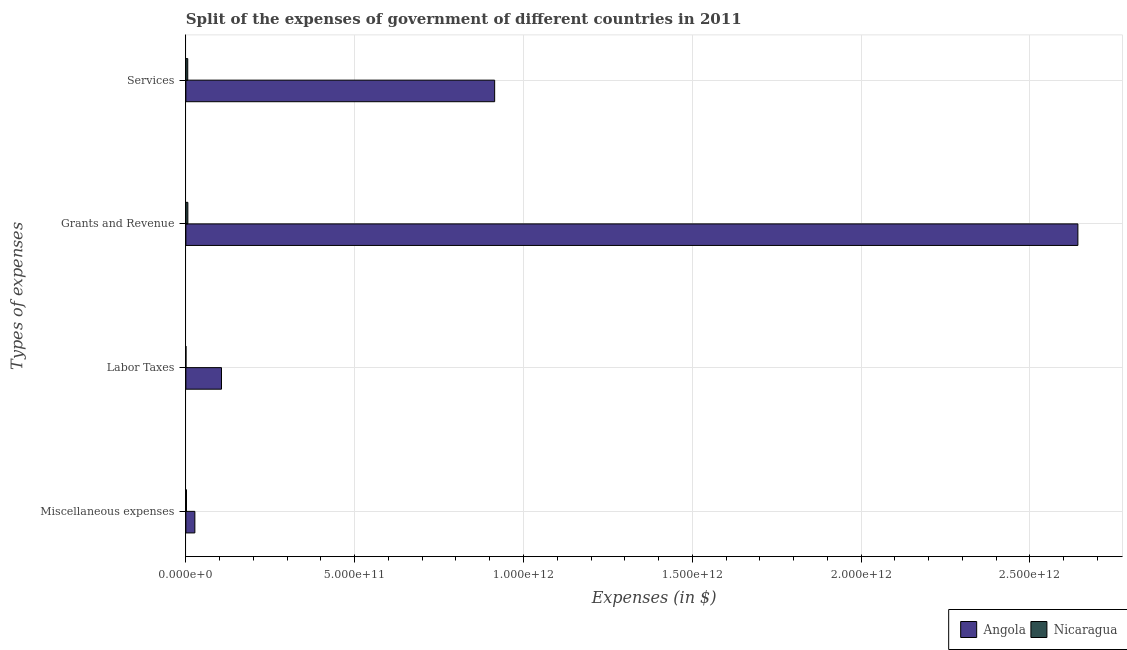Are the number of bars per tick equal to the number of legend labels?
Your answer should be very brief. Yes. How many bars are there on the 1st tick from the top?
Your response must be concise. 2. How many bars are there on the 3rd tick from the bottom?
Keep it short and to the point. 2. What is the label of the 4th group of bars from the top?
Ensure brevity in your answer.  Miscellaneous expenses. What is the amount spent on services in Angola?
Give a very brief answer. 9.15e+11. Across all countries, what is the maximum amount spent on grants and revenue?
Provide a succinct answer. 2.64e+12. Across all countries, what is the minimum amount spent on services?
Offer a terse response. 5.54e+09. In which country was the amount spent on services maximum?
Give a very brief answer. Angola. In which country was the amount spent on services minimum?
Make the answer very short. Nicaragua. What is the total amount spent on miscellaneous expenses in the graph?
Your answer should be very brief. 2.84e+1. What is the difference between the amount spent on miscellaneous expenses in Nicaragua and that in Angola?
Provide a short and direct response. -2.48e+1. What is the difference between the amount spent on miscellaneous expenses in Nicaragua and the amount spent on grants and revenue in Angola?
Your response must be concise. -2.64e+12. What is the average amount spent on grants and revenue per country?
Ensure brevity in your answer.  1.32e+12. What is the difference between the amount spent on miscellaneous expenses and amount spent on labor taxes in Nicaragua?
Keep it short and to the point. 1.59e+09. In how many countries, is the amount spent on miscellaneous expenses greater than 500000000000 $?
Your answer should be very brief. 0. What is the ratio of the amount spent on grants and revenue in Angola to that in Nicaragua?
Provide a succinct answer. 450.04. What is the difference between the highest and the second highest amount spent on services?
Your response must be concise. 9.09e+11. What is the difference between the highest and the lowest amount spent on miscellaneous expenses?
Offer a terse response. 2.48e+1. In how many countries, is the amount spent on labor taxes greater than the average amount spent on labor taxes taken over all countries?
Your answer should be compact. 1. What does the 2nd bar from the top in Services represents?
Keep it short and to the point. Angola. What does the 1st bar from the bottom in Miscellaneous expenses represents?
Ensure brevity in your answer.  Angola. Is it the case that in every country, the sum of the amount spent on miscellaneous expenses and amount spent on labor taxes is greater than the amount spent on grants and revenue?
Offer a very short reply. No. Are all the bars in the graph horizontal?
Ensure brevity in your answer.  Yes. How many countries are there in the graph?
Ensure brevity in your answer.  2. What is the difference between two consecutive major ticks on the X-axis?
Make the answer very short. 5.00e+11. Does the graph contain any zero values?
Provide a succinct answer. No. Does the graph contain grids?
Your answer should be compact. Yes. Where does the legend appear in the graph?
Provide a short and direct response. Bottom right. How many legend labels are there?
Keep it short and to the point. 2. How are the legend labels stacked?
Your answer should be compact. Horizontal. What is the title of the graph?
Offer a very short reply. Split of the expenses of government of different countries in 2011. Does "Burkina Faso" appear as one of the legend labels in the graph?
Keep it short and to the point. No. What is the label or title of the X-axis?
Keep it short and to the point. Expenses (in $). What is the label or title of the Y-axis?
Ensure brevity in your answer.  Types of expenses. What is the Expenses (in $) in Angola in Miscellaneous expenses?
Give a very brief answer. 2.66e+1. What is the Expenses (in $) of Nicaragua in Miscellaneous expenses?
Ensure brevity in your answer.  1.80e+09. What is the Expenses (in $) in Angola in Labor Taxes?
Make the answer very short. 1.06e+11. What is the Expenses (in $) of Nicaragua in Labor Taxes?
Give a very brief answer. 2.13e+08. What is the Expenses (in $) in Angola in Grants and Revenue?
Provide a succinct answer. 2.64e+12. What is the Expenses (in $) in Nicaragua in Grants and Revenue?
Make the answer very short. 5.87e+09. What is the Expenses (in $) in Angola in Services?
Provide a short and direct response. 9.15e+11. What is the Expenses (in $) of Nicaragua in Services?
Your answer should be very brief. 5.54e+09. Across all Types of expenses, what is the maximum Expenses (in $) in Angola?
Your answer should be compact. 2.64e+12. Across all Types of expenses, what is the maximum Expenses (in $) of Nicaragua?
Your answer should be very brief. 5.87e+09. Across all Types of expenses, what is the minimum Expenses (in $) of Angola?
Provide a short and direct response. 2.66e+1. Across all Types of expenses, what is the minimum Expenses (in $) of Nicaragua?
Keep it short and to the point. 2.13e+08. What is the total Expenses (in $) of Angola in the graph?
Your answer should be very brief. 3.69e+12. What is the total Expenses (in $) of Nicaragua in the graph?
Your response must be concise. 1.34e+1. What is the difference between the Expenses (in $) of Angola in Miscellaneous expenses and that in Labor Taxes?
Give a very brief answer. -7.89e+1. What is the difference between the Expenses (in $) of Nicaragua in Miscellaneous expenses and that in Labor Taxes?
Give a very brief answer. 1.59e+09. What is the difference between the Expenses (in $) in Angola in Miscellaneous expenses and that in Grants and Revenue?
Offer a very short reply. -2.62e+12. What is the difference between the Expenses (in $) in Nicaragua in Miscellaneous expenses and that in Grants and Revenue?
Make the answer very short. -4.07e+09. What is the difference between the Expenses (in $) in Angola in Miscellaneous expenses and that in Services?
Your answer should be very brief. -8.88e+11. What is the difference between the Expenses (in $) in Nicaragua in Miscellaneous expenses and that in Services?
Your answer should be very brief. -3.74e+09. What is the difference between the Expenses (in $) of Angola in Labor Taxes and that in Grants and Revenue?
Provide a succinct answer. -2.54e+12. What is the difference between the Expenses (in $) of Nicaragua in Labor Taxes and that in Grants and Revenue?
Give a very brief answer. -5.66e+09. What is the difference between the Expenses (in $) in Angola in Labor Taxes and that in Services?
Provide a succinct answer. -8.09e+11. What is the difference between the Expenses (in $) in Nicaragua in Labor Taxes and that in Services?
Offer a very short reply. -5.32e+09. What is the difference between the Expenses (in $) in Angola in Grants and Revenue and that in Services?
Your response must be concise. 1.73e+12. What is the difference between the Expenses (in $) in Nicaragua in Grants and Revenue and that in Services?
Provide a succinct answer. 3.34e+08. What is the difference between the Expenses (in $) of Angola in Miscellaneous expenses and the Expenses (in $) of Nicaragua in Labor Taxes?
Your response must be concise. 2.64e+1. What is the difference between the Expenses (in $) of Angola in Miscellaneous expenses and the Expenses (in $) of Nicaragua in Grants and Revenue?
Your answer should be compact. 2.07e+1. What is the difference between the Expenses (in $) of Angola in Miscellaneous expenses and the Expenses (in $) of Nicaragua in Services?
Keep it short and to the point. 2.11e+1. What is the difference between the Expenses (in $) of Angola in Labor Taxes and the Expenses (in $) of Nicaragua in Grants and Revenue?
Give a very brief answer. 9.96e+1. What is the difference between the Expenses (in $) in Angola in Labor Taxes and the Expenses (in $) in Nicaragua in Services?
Keep it short and to the point. 1.00e+11. What is the difference between the Expenses (in $) in Angola in Grants and Revenue and the Expenses (in $) in Nicaragua in Services?
Provide a succinct answer. 2.64e+12. What is the average Expenses (in $) of Angola per Types of expenses?
Your answer should be compact. 9.22e+11. What is the average Expenses (in $) of Nicaragua per Types of expenses?
Provide a short and direct response. 3.36e+09. What is the difference between the Expenses (in $) in Angola and Expenses (in $) in Nicaragua in Miscellaneous expenses?
Provide a succinct answer. 2.48e+1. What is the difference between the Expenses (in $) in Angola and Expenses (in $) in Nicaragua in Labor Taxes?
Provide a short and direct response. 1.05e+11. What is the difference between the Expenses (in $) in Angola and Expenses (in $) in Nicaragua in Grants and Revenue?
Keep it short and to the point. 2.64e+12. What is the difference between the Expenses (in $) in Angola and Expenses (in $) in Nicaragua in Services?
Your response must be concise. 9.09e+11. What is the ratio of the Expenses (in $) in Angola in Miscellaneous expenses to that in Labor Taxes?
Make the answer very short. 0.25. What is the ratio of the Expenses (in $) in Nicaragua in Miscellaneous expenses to that in Labor Taxes?
Your answer should be very brief. 8.44. What is the ratio of the Expenses (in $) of Angola in Miscellaneous expenses to that in Grants and Revenue?
Offer a terse response. 0.01. What is the ratio of the Expenses (in $) of Nicaragua in Miscellaneous expenses to that in Grants and Revenue?
Ensure brevity in your answer.  0.31. What is the ratio of the Expenses (in $) in Angola in Miscellaneous expenses to that in Services?
Your answer should be compact. 0.03. What is the ratio of the Expenses (in $) in Nicaragua in Miscellaneous expenses to that in Services?
Give a very brief answer. 0.32. What is the ratio of the Expenses (in $) of Angola in Labor Taxes to that in Grants and Revenue?
Make the answer very short. 0.04. What is the ratio of the Expenses (in $) of Nicaragua in Labor Taxes to that in Grants and Revenue?
Make the answer very short. 0.04. What is the ratio of the Expenses (in $) of Angola in Labor Taxes to that in Services?
Provide a short and direct response. 0.12. What is the ratio of the Expenses (in $) of Nicaragua in Labor Taxes to that in Services?
Your answer should be compact. 0.04. What is the ratio of the Expenses (in $) of Angola in Grants and Revenue to that in Services?
Make the answer very short. 2.89. What is the ratio of the Expenses (in $) in Nicaragua in Grants and Revenue to that in Services?
Provide a short and direct response. 1.06. What is the difference between the highest and the second highest Expenses (in $) of Angola?
Provide a short and direct response. 1.73e+12. What is the difference between the highest and the second highest Expenses (in $) in Nicaragua?
Your response must be concise. 3.34e+08. What is the difference between the highest and the lowest Expenses (in $) in Angola?
Your response must be concise. 2.62e+12. What is the difference between the highest and the lowest Expenses (in $) in Nicaragua?
Offer a very short reply. 5.66e+09. 